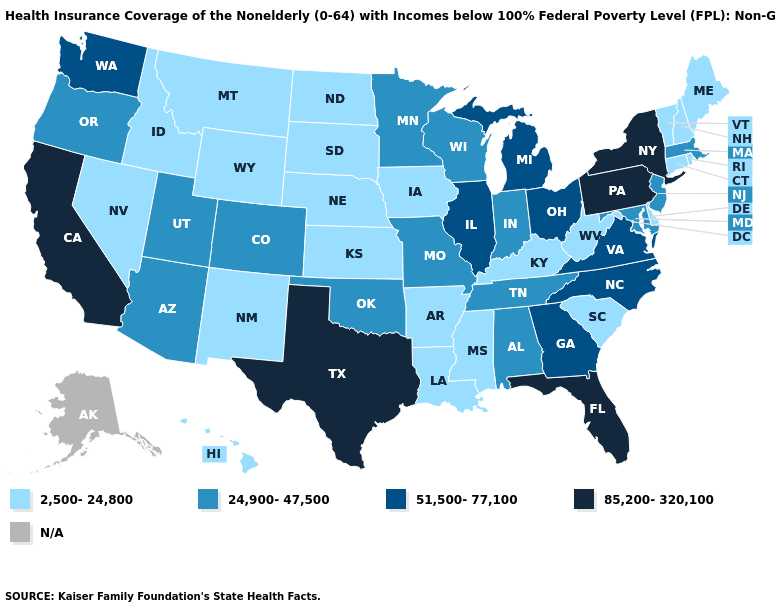What is the lowest value in the USA?
Short answer required. 2,500-24,800. Does Texas have the lowest value in the USA?
Quick response, please. No. How many symbols are there in the legend?
Be succinct. 5. Does Maine have the highest value in the Northeast?
Quick response, please. No. Name the states that have a value in the range 85,200-320,100?
Concise answer only. California, Florida, New York, Pennsylvania, Texas. Name the states that have a value in the range 51,500-77,100?
Give a very brief answer. Georgia, Illinois, Michigan, North Carolina, Ohio, Virginia, Washington. Among the states that border West Virginia , does Virginia have the highest value?
Write a very short answer. No. Does Idaho have the highest value in the West?
Give a very brief answer. No. Name the states that have a value in the range 51,500-77,100?
Quick response, please. Georgia, Illinois, Michigan, North Carolina, Ohio, Virginia, Washington. What is the highest value in the West ?
Write a very short answer. 85,200-320,100. Name the states that have a value in the range 2,500-24,800?
Answer briefly. Arkansas, Connecticut, Delaware, Hawaii, Idaho, Iowa, Kansas, Kentucky, Louisiana, Maine, Mississippi, Montana, Nebraska, Nevada, New Hampshire, New Mexico, North Dakota, Rhode Island, South Carolina, South Dakota, Vermont, West Virginia, Wyoming. What is the lowest value in the USA?
Answer briefly. 2,500-24,800. Is the legend a continuous bar?
Give a very brief answer. No. Which states have the lowest value in the USA?
Be succinct. Arkansas, Connecticut, Delaware, Hawaii, Idaho, Iowa, Kansas, Kentucky, Louisiana, Maine, Mississippi, Montana, Nebraska, Nevada, New Hampshire, New Mexico, North Dakota, Rhode Island, South Carolina, South Dakota, Vermont, West Virginia, Wyoming. 